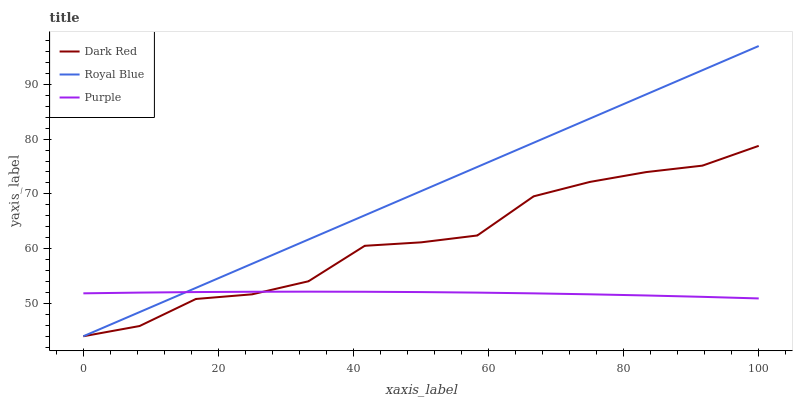Does Purple have the minimum area under the curve?
Answer yes or no. Yes. Does Royal Blue have the maximum area under the curve?
Answer yes or no. Yes. Does Dark Red have the minimum area under the curve?
Answer yes or no. No. Does Dark Red have the maximum area under the curve?
Answer yes or no. No. Is Royal Blue the smoothest?
Answer yes or no. Yes. Is Dark Red the roughest?
Answer yes or no. Yes. Is Dark Red the smoothest?
Answer yes or no. No. Is Royal Blue the roughest?
Answer yes or no. No. Does Dark Red have the lowest value?
Answer yes or no. Yes. Does Royal Blue have the highest value?
Answer yes or no. Yes. Does Dark Red have the highest value?
Answer yes or no. No. Does Dark Red intersect Royal Blue?
Answer yes or no. Yes. Is Dark Red less than Royal Blue?
Answer yes or no. No. Is Dark Red greater than Royal Blue?
Answer yes or no. No. 